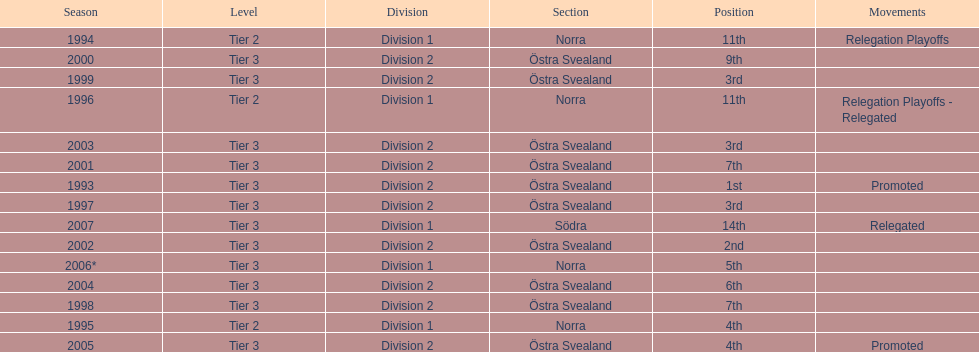What year is at least on the list? 2007. Could you parse the entire table as a dict? {'header': ['Season', 'Level', 'Division', 'Section', 'Position', 'Movements'], 'rows': [['1994', 'Tier 2', 'Division 1', 'Norra', '11th', 'Relegation Playoffs'], ['2000', 'Tier 3', 'Division 2', 'Östra Svealand', '9th', ''], ['1999', 'Tier 3', 'Division 2', 'Östra Svealand', '3rd', ''], ['1996', 'Tier 2', 'Division 1', 'Norra', '11th', 'Relegation Playoffs - Relegated'], ['2003', 'Tier 3', 'Division 2', 'Östra Svealand', '3rd', ''], ['2001', 'Tier 3', 'Division 2', 'Östra Svealand', '7th', ''], ['1993', 'Tier 3', 'Division 2', 'Östra Svealand', '1st', 'Promoted'], ['1997', 'Tier 3', 'Division 2', 'Östra Svealand', '3rd', ''], ['2007', 'Tier 3', 'Division 1', 'Södra', '14th', 'Relegated'], ['2002', 'Tier 3', 'Division 2', 'Östra Svealand', '2nd', ''], ['2006*', 'Tier 3', 'Division 1', 'Norra', '5th', ''], ['2004', 'Tier 3', 'Division 2', 'Östra Svealand', '6th', ''], ['1998', 'Tier 3', 'Division 2', 'Östra Svealand', '7th', ''], ['1995', 'Tier 2', 'Division 1', 'Norra', '4th', ''], ['2005', 'Tier 3', 'Division 2', 'Östra Svealand', '4th', 'Promoted']]} 